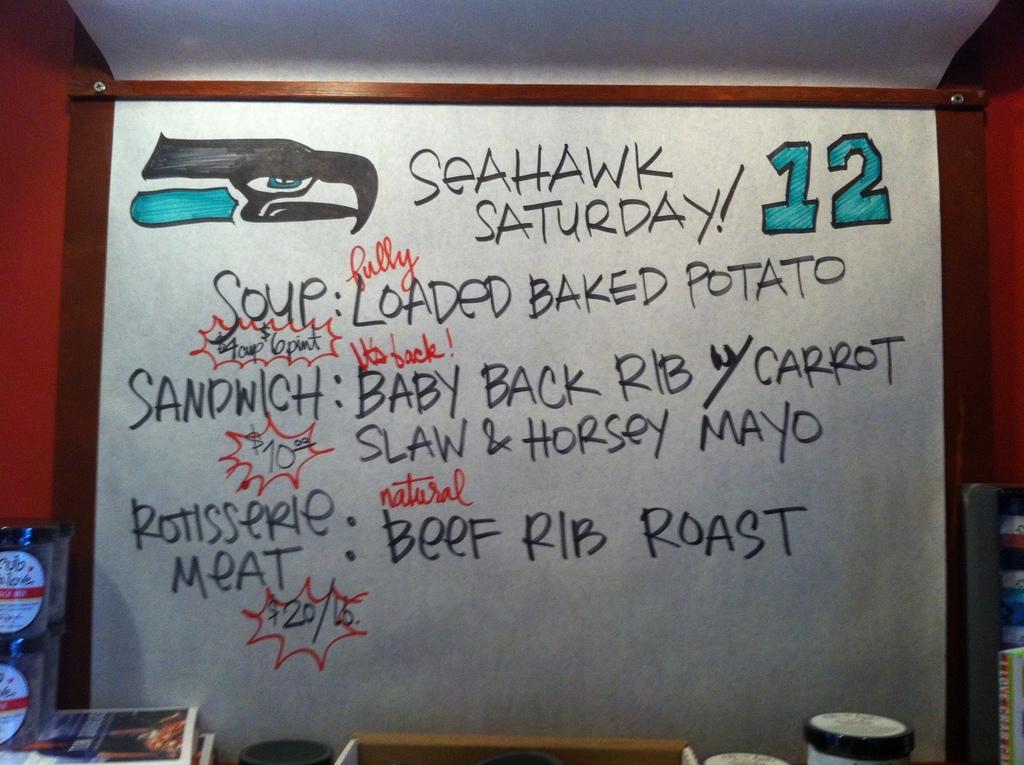What is the green number in the right corner?
Your answer should be very brief. 12. What is the soup of the day?
Your answer should be very brief. Loaded baked potato. 